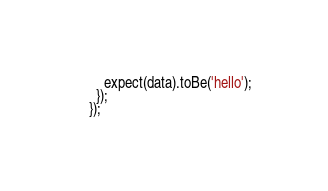<code> <loc_0><loc_0><loc_500><loc_500><_TypeScript_>    expect(data).toBe('hello');
  });
});
</code> 